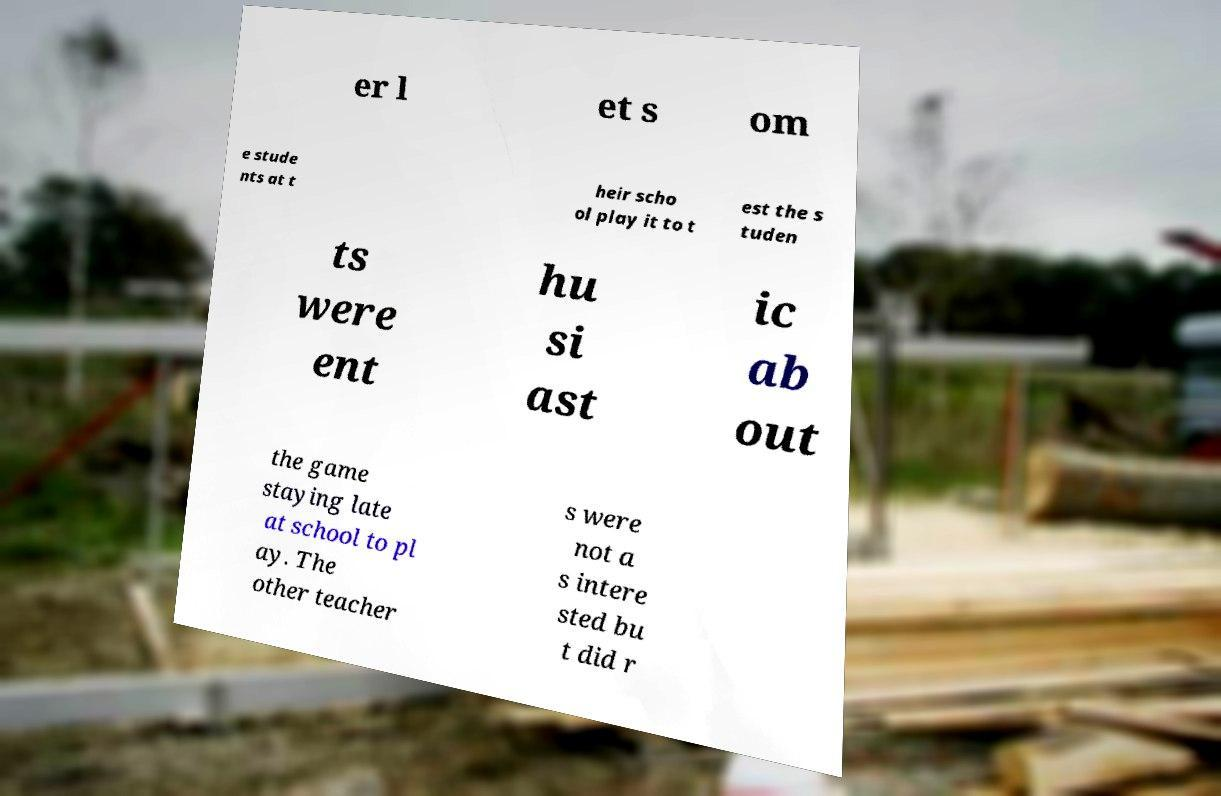Can you accurately transcribe the text from the provided image for me? er l et s om e stude nts at t heir scho ol play it to t est the s tuden ts were ent hu si ast ic ab out the game staying late at school to pl ay. The other teacher s were not a s intere sted bu t did r 